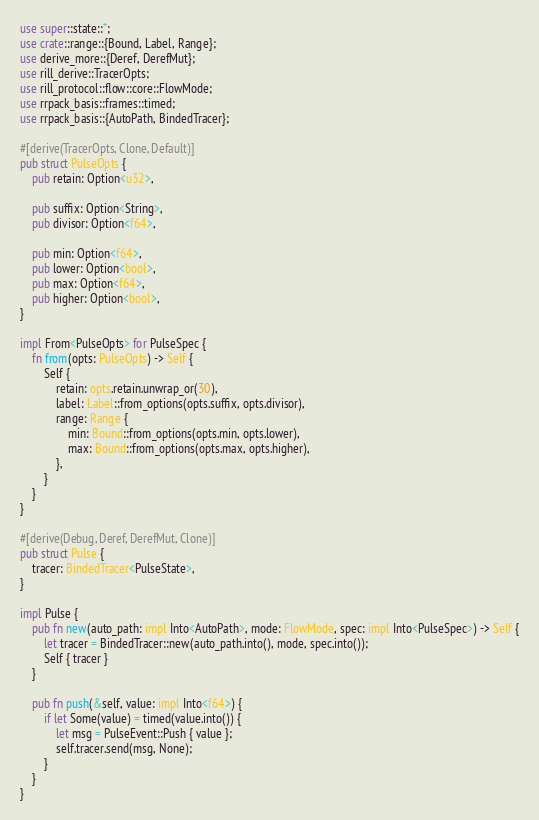<code> <loc_0><loc_0><loc_500><loc_500><_Rust_>use super::state::*;
use crate::range::{Bound, Label, Range};
use derive_more::{Deref, DerefMut};
use rill_derive::TracerOpts;
use rill_protocol::flow::core::FlowMode;
use rrpack_basis::frames::timed;
use rrpack_basis::{AutoPath, BindedTracer};

#[derive(TracerOpts, Clone, Default)]
pub struct PulseOpts {
    pub retain: Option<u32>,

    pub suffix: Option<String>,
    pub divisor: Option<f64>,

    pub min: Option<f64>,
    pub lower: Option<bool>,
    pub max: Option<f64>,
    pub higher: Option<bool>,
}

impl From<PulseOpts> for PulseSpec {
    fn from(opts: PulseOpts) -> Self {
        Self {
            retain: opts.retain.unwrap_or(30),
            label: Label::from_options(opts.suffix, opts.divisor),
            range: Range {
                min: Bound::from_options(opts.min, opts.lower),
                max: Bound::from_options(opts.max, opts.higher),
            },
        }
    }
}

#[derive(Debug, Deref, DerefMut, Clone)]
pub struct Pulse {
    tracer: BindedTracer<PulseState>,
}

impl Pulse {
    pub fn new(auto_path: impl Into<AutoPath>, mode: FlowMode, spec: impl Into<PulseSpec>) -> Self {
        let tracer = BindedTracer::new(auto_path.into(), mode, spec.into());
        Self { tracer }
    }

    pub fn push(&self, value: impl Into<f64>) {
        if let Some(value) = timed(value.into()) {
            let msg = PulseEvent::Push { value };
            self.tracer.send(msg, None);
        }
    }
}
</code> 